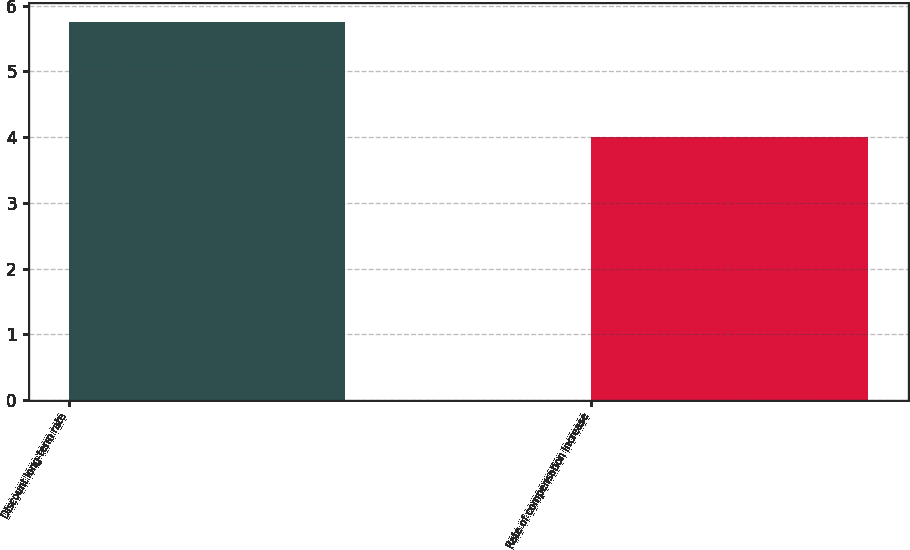<chart> <loc_0><loc_0><loc_500><loc_500><bar_chart><fcel>Discount long-term rate<fcel>Rate of compensation increase<nl><fcel>5.75<fcel>4<nl></chart> 